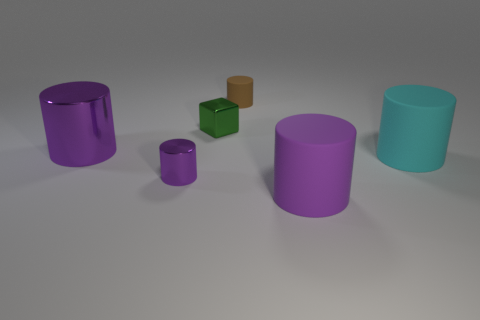Subtract all purple cylinders. How many were subtracted if there are1purple cylinders left? 2 Add 3 tiny brown objects. How many objects exist? 9 Subtract all small brown matte cylinders. How many cylinders are left? 4 Subtract 1 cylinders. How many cylinders are left? 4 Subtract all green spheres. How many purple cylinders are left? 3 Subtract all cyan cylinders. How many cylinders are left? 4 Subtract 0 brown cubes. How many objects are left? 6 Subtract all cylinders. How many objects are left? 1 Subtract all blue cylinders. Subtract all purple spheres. How many cylinders are left? 5 Subtract all large blue cubes. Subtract all brown matte cylinders. How many objects are left? 5 